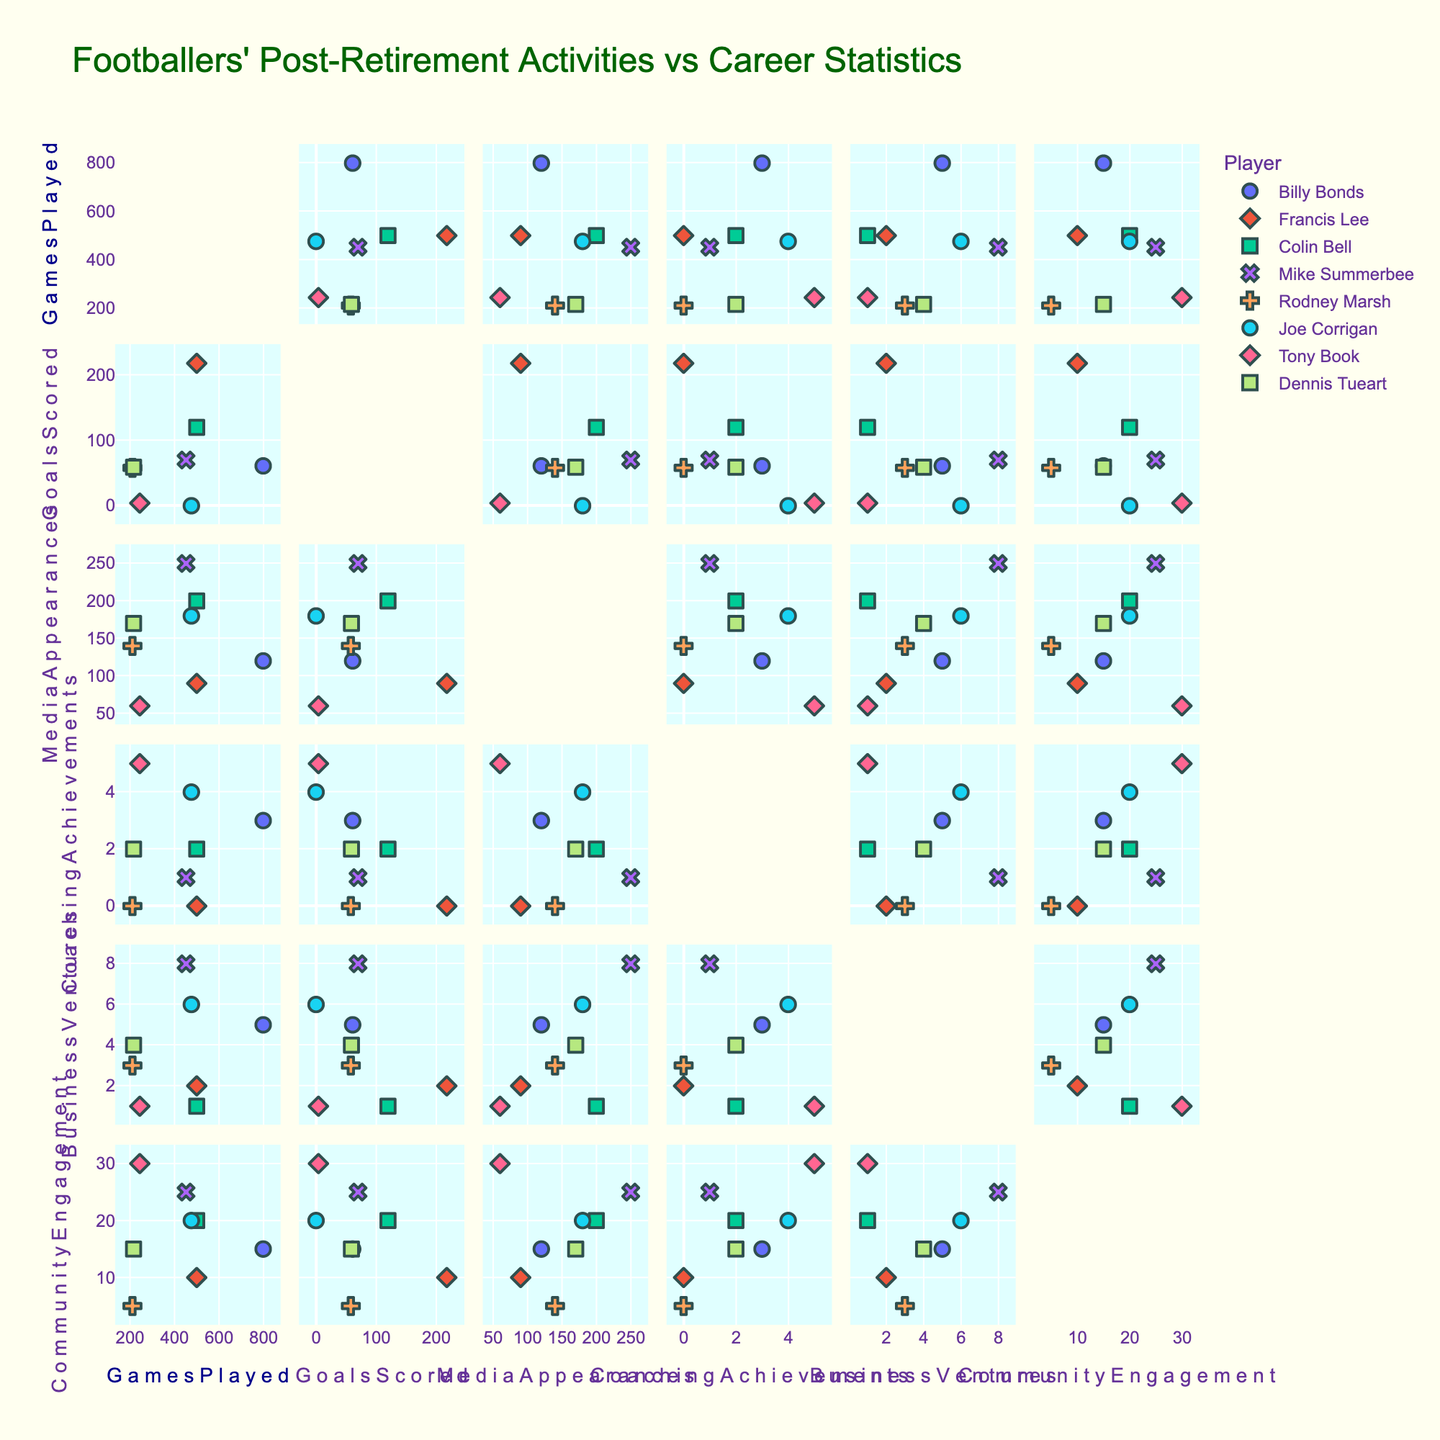What is the title of the scatter plot matrix? The title is typically found at the top of the figure. It provides an overview of what the plot represents. In this case, it would describe the correlation between footballers' post-retirement activities and their career statistics.
Answer: Footballers' Post-Retirement Activities vs Career Statistics How many data points are associated with each player? Each player has one data point for each pair of the six numeric columns. This results in \({n_C2}\) unique pairs of attributes per player, but the exact number of data points can be observed directly in the SPLOM. Each column pair will have a single point for each player.
Answer: 8 points per player per scatter plot Which player has the highest number of Media Appearances and how can you tell? To identify this, look at the 'Media Appearances' dimension across all players and find the maximum value. Check the color or symbol associated with the player linked to this value.
Answer: Mike Summerbee Is there a visible correlation between 'GoalsScored' and 'MediaAppearances'? By examining the scatter plot for the pair 'GoalsScored' vs 'MediaAppearances’, one can identify if there is any particular trend or pattern. A correlation would appear as an upward or downward trend amongst the points.
Answer: Not strongly correlated Which player appears to have the highest level of Community Engagement? Locate the 'Community Engagement' axis and identify the maximum value. Then, refer to the corresponding player color or symbol to determine the player.
Answer: Tony Book Who has a perfect zero 'GoalsScored' despite numerous appearances in coaching? Look for data points where 'GoalsScored' is zero and cross-reference with 'CoachingAchievements'.
Answer: Joe Corrigan What is the average number of 'CoachingAchievements' among all players? Sum the 'CoachingAchievements' values for all players and divide by the number of players, which is 8. (3+0+2+1+0+4+5+2)/8
Answer: 2.125 Between ‘GamesPlayed’ and ‘BusinessVentures’, which player stands out with notably high values for both? Identify pairs of 'GamesPlayed' and 'BusinessVentures' and look for a point with high values on both axes.
Answer: Mike Summerbee Are players with more 'GamesPlayed' more involved in 'CommunityEngagement’? By examining the scatter plot between 'GamesPlayed' and 'CommunityEngagement', one can visualize if a higher count in games correlates with higher community engagement values.
Answer: Not obviously correlated Which player has an atypical combination of a high number of 'GamesPlayed' but a low number of 'GoalsScored'? Look at the plot for 'GamesPlayed' versus 'GoalsScored’ and find a point at the extreme end of 'GamesPlayed' with a low 'GoalsScored' value.
Answer: Joe Corrigan 